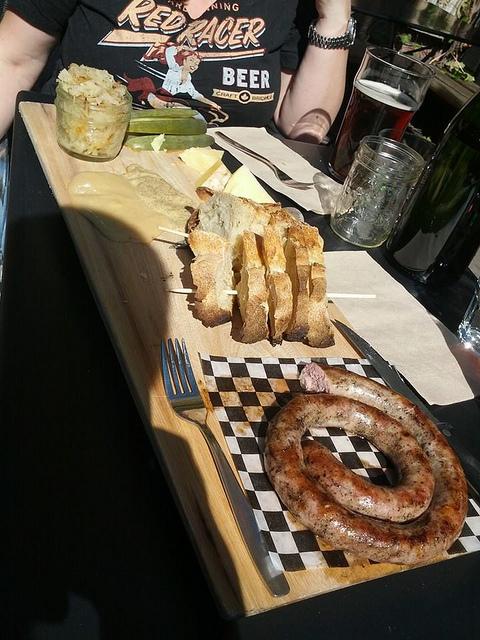What type of beer is advertises?
Keep it brief. Red racer. Is there a shadow in the photo?
Short answer required. Yes. What foods are pictured?
Answer briefly. Sausage, bread, cheese, pickles. 